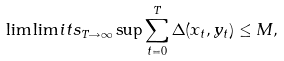Convert formula to latex. <formula><loc_0><loc_0><loc_500><loc_500>\lim \lim i t s _ { T \rightarrow \infty } \sup \sum _ { t = 0 } ^ { T } \Delta ( x _ { t } , y _ { t } ) \leq M ,</formula> 